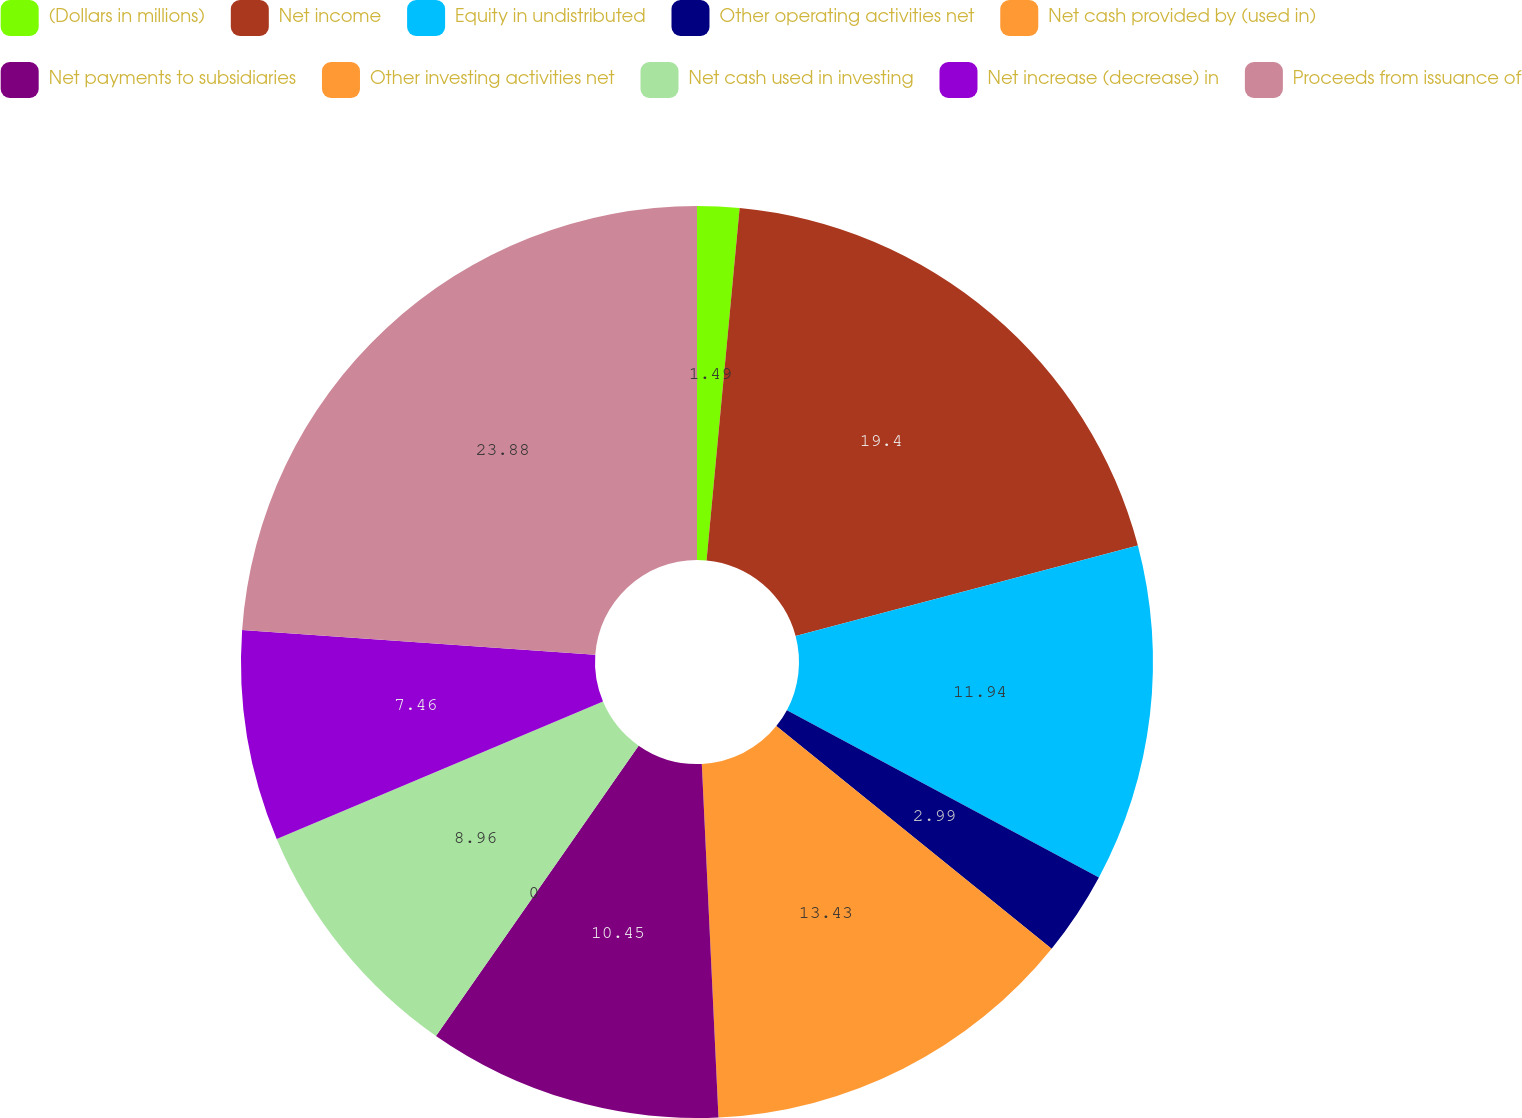Convert chart to OTSL. <chart><loc_0><loc_0><loc_500><loc_500><pie_chart><fcel>(Dollars in millions)<fcel>Net income<fcel>Equity in undistributed<fcel>Other operating activities net<fcel>Net cash provided by (used in)<fcel>Net payments to subsidiaries<fcel>Other investing activities net<fcel>Net cash used in investing<fcel>Net increase (decrease) in<fcel>Proceeds from issuance of<nl><fcel>1.49%<fcel>19.4%<fcel>11.94%<fcel>2.99%<fcel>13.43%<fcel>10.45%<fcel>0.0%<fcel>8.96%<fcel>7.46%<fcel>23.88%<nl></chart> 